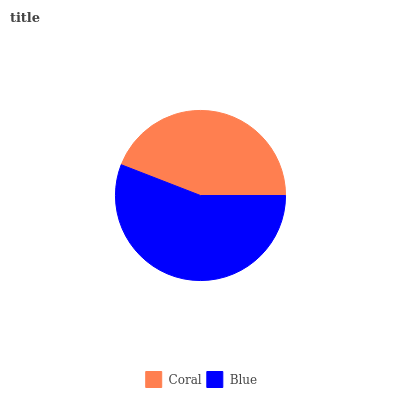Is Coral the minimum?
Answer yes or no. Yes. Is Blue the maximum?
Answer yes or no. Yes. Is Blue the minimum?
Answer yes or no. No. Is Blue greater than Coral?
Answer yes or no. Yes. Is Coral less than Blue?
Answer yes or no. Yes. Is Coral greater than Blue?
Answer yes or no. No. Is Blue less than Coral?
Answer yes or no. No. Is Blue the high median?
Answer yes or no. Yes. Is Coral the low median?
Answer yes or no. Yes. Is Coral the high median?
Answer yes or no. No. Is Blue the low median?
Answer yes or no. No. 